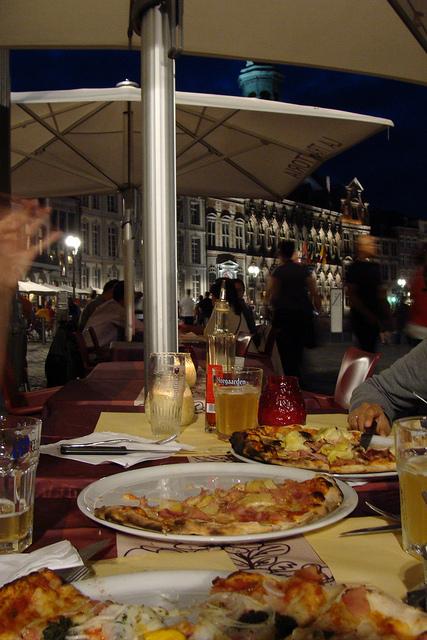What type of scene is this?
Be succinct. Restaurant. What time of day is this?
Quick response, please. Night. Are these people drinking beer?
Concise answer only. Yes. 